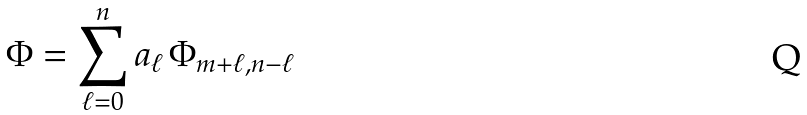<formula> <loc_0><loc_0><loc_500><loc_500>\Phi = \sum _ { \ell = 0 } ^ { n } a _ { \ell } \, \Phi _ { m + \ell , n - \ell }</formula> 